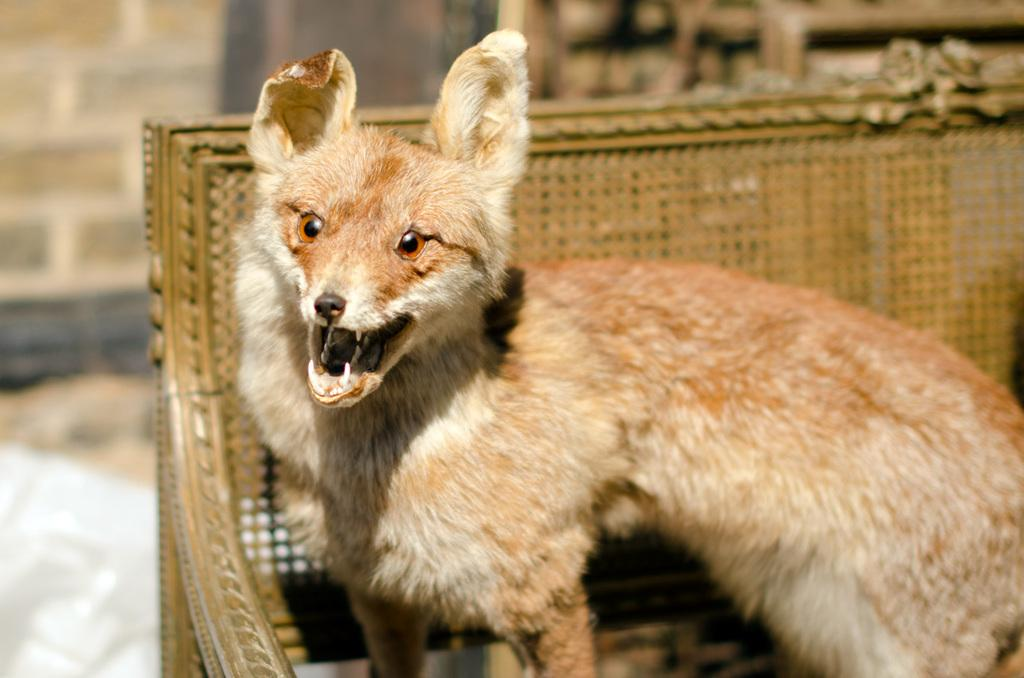What type of creature is in the image? There is an animal in the image. Where is the animal positioned in the image? The animal is standing on a bench. What colors can be seen on the animal? The animal is in brown and cream color. What color is the bench in the image? The bench is in cream color. How would you describe the background of the image? The background of the image is blurred. What type of flower is the animal holding in its mouth in the image? There is no flower present in the image, and the animal is not holding anything in its mouth. 